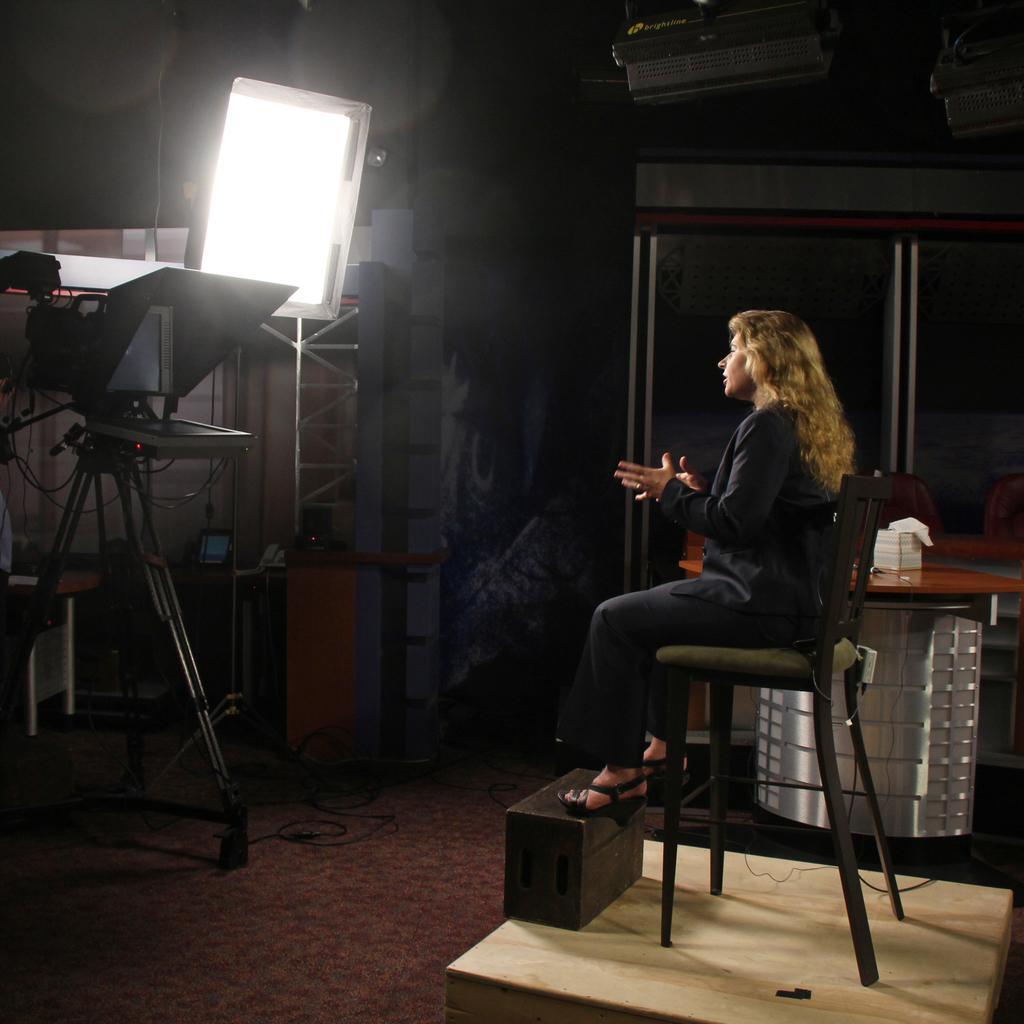In one or two sentences, can you explain what this image depicts? In the picture, it looks like a shooting, a woman is sitting on the chair, she is acting,in front of her there is a big camera and beside that there is a light,in the background there are some cupboards,to the right side of the woman there are some other equipment,there are some lights to the roof. 